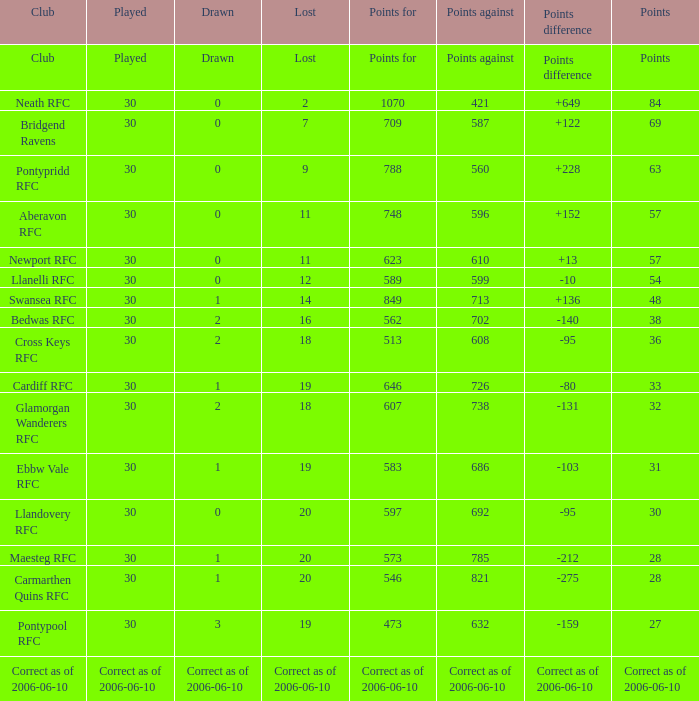What is Points, when Points For is "562"? 38.0. 